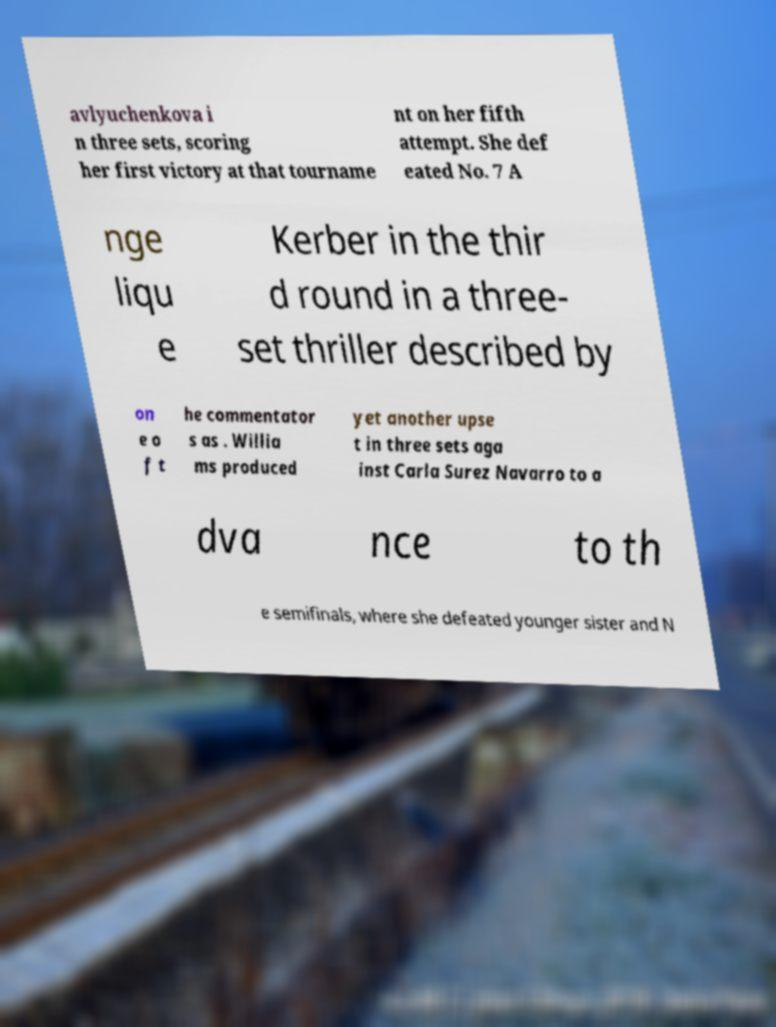Please identify and transcribe the text found in this image. avlyuchenkova i n three sets, scoring her first victory at that tourname nt on her fifth attempt. She def eated No. 7 A nge liqu e Kerber in the thir d round in a three- set thriller described by on e o f t he commentator s as . Willia ms produced yet another upse t in three sets aga inst Carla Surez Navarro to a dva nce to th e semifinals, where she defeated younger sister and N 